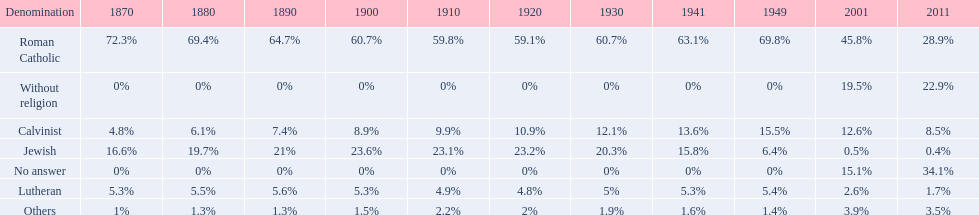In which year was the percentage of those without religion at least 20%? 2011. 